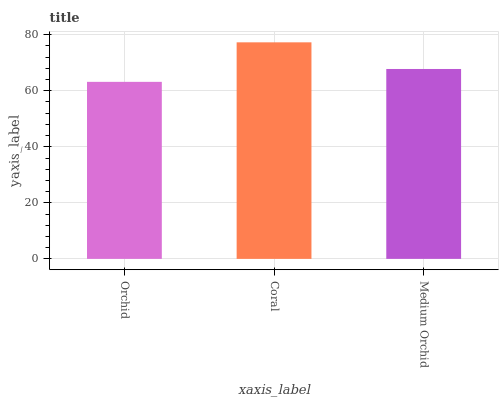Is Orchid the minimum?
Answer yes or no. Yes. Is Coral the maximum?
Answer yes or no. Yes. Is Medium Orchid the minimum?
Answer yes or no. No. Is Medium Orchid the maximum?
Answer yes or no. No. Is Coral greater than Medium Orchid?
Answer yes or no. Yes. Is Medium Orchid less than Coral?
Answer yes or no. Yes. Is Medium Orchid greater than Coral?
Answer yes or no. No. Is Coral less than Medium Orchid?
Answer yes or no. No. Is Medium Orchid the high median?
Answer yes or no. Yes. Is Medium Orchid the low median?
Answer yes or no. Yes. Is Coral the high median?
Answer yes or no. No. Is Coral the low median?
Answer yes or no. No. 